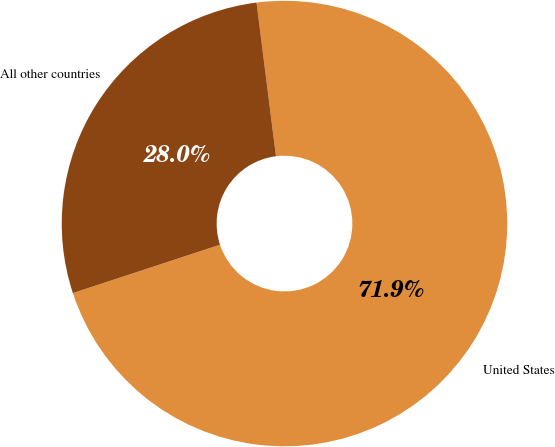Convert chart to OTSL. <chart><loc_0><loc_0><loc_500><loc_500><pie_chart><fcel>United States<fcel>All other countries<nl><fcel>71.95%<fcel>28.05%<nl></chart> 